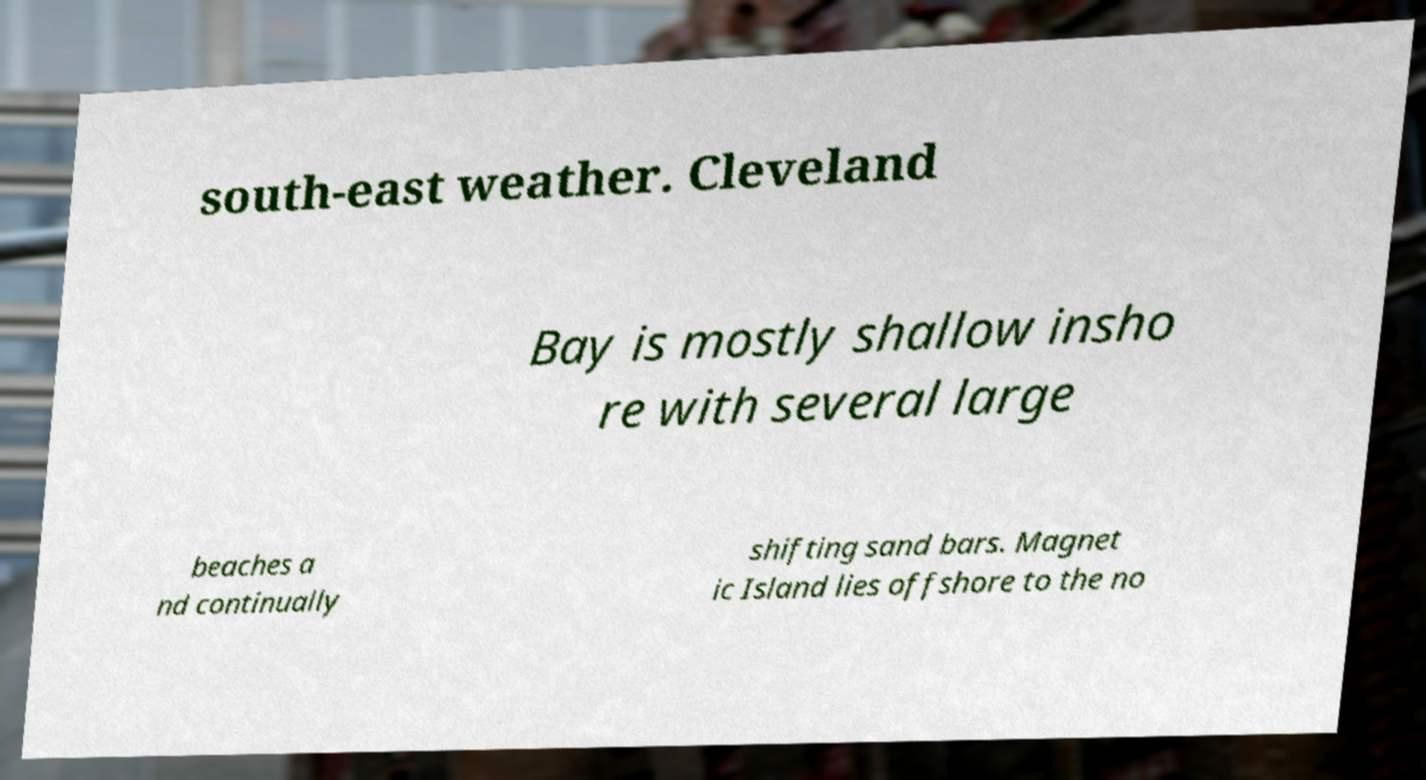What messages or text are displayed in this image? I need them in a readable, typed format. south-east weather. Cleveland Bay is mostly shallow insho re with several large beaches a nd continually shifting sand bars. Magnet ic Island lies offshore to the no 